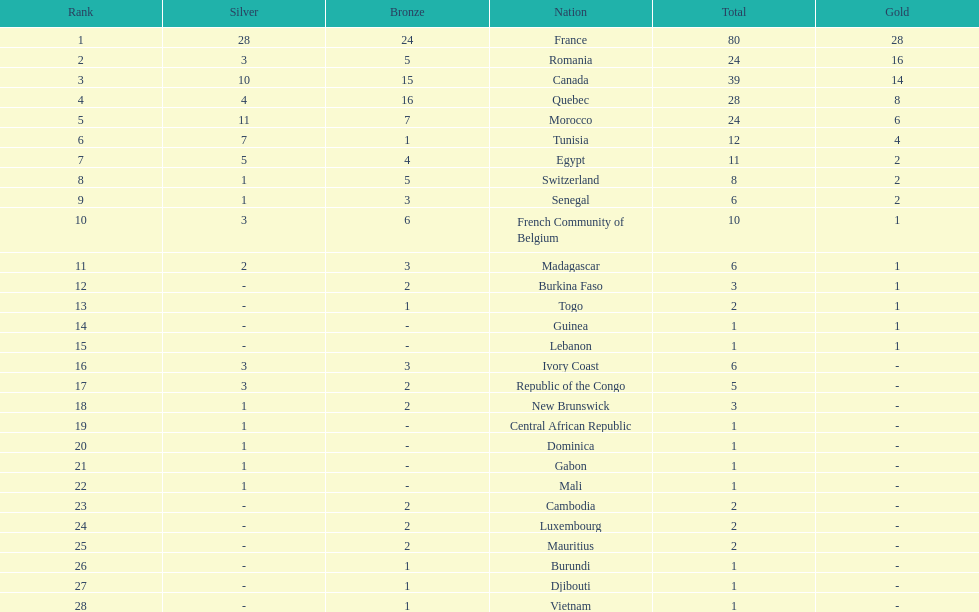Who placed in first according to medals? France. 